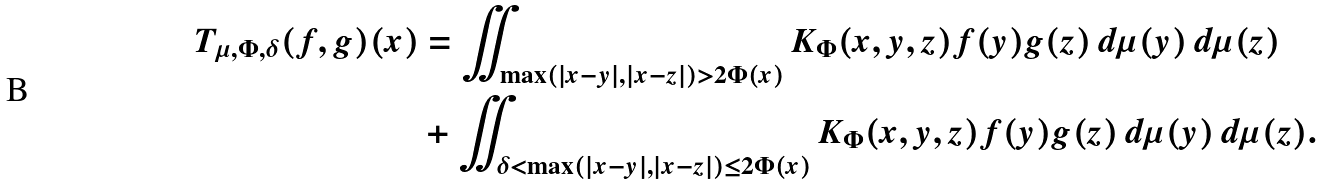<formula> <loc_0><loc_0><loc_500><loc_500>T _ { \mu , \Phi , \delta } ( f , g ) ( x ) & = \iint _ { \max ( | x - y | , | x - z | ) > 2 \Phi ( x ) } K _ { \Phi } ( x , y , z ) f ( y ) g ( z ) \, d \mu ( y ) \, d \mu ( z ) \\ & + \iint _ { \delta < \max ( | x - y | , | x - z | ) \leq 2 \Phi ( x ) } K _ { \Phi } ( x , y , z ) f ( y ) g ( z ) \, d \mu ( y ) \, d \mu ( z ) .</formula> 